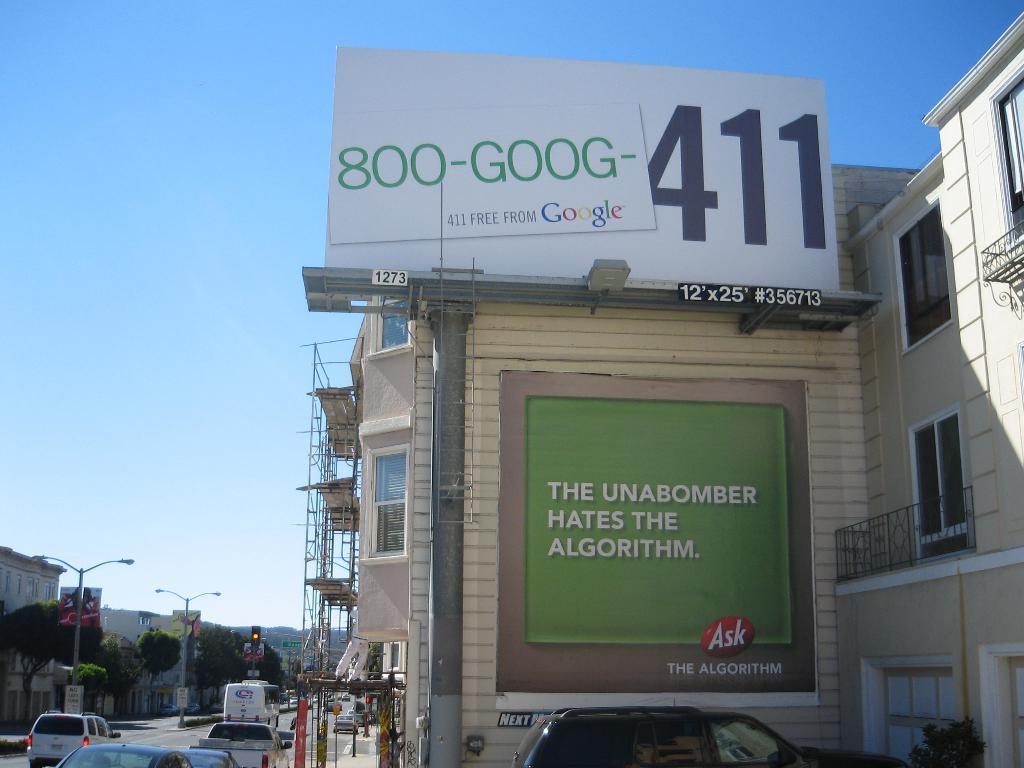Describe this image in one or two sentences. In the foreground of this image, on the right, there is a vehicle on the bottom in the background, there is a building with hoarding, pole, poster, railing and with few windows. On the left, there is a road on which vehicles are moving and also poles, trees, buildings, a traffic signal pole and the sky. 